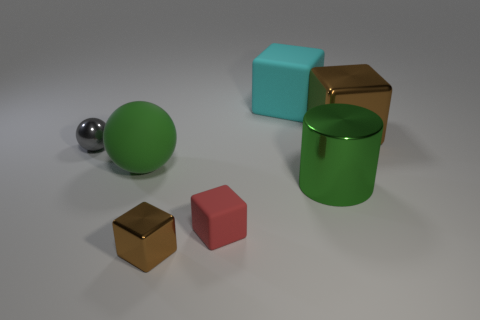What color is the small block in front of the tiny rubber object that is to the right of the brown metallic block in front of the red rubber block?
Provide a succinct answer. Brown. What is the shape of the brown metallic thing that is the same size as the cyan matte block?
Provide a short and direct response. Cube. Do the metallic block to the right of the tiny brown thing and the brown shiny thing that is on the left side of the large cyan matte block have the same size?
Your response must be concise. No. There is a rubber thing that is behind the matte sphere; what is its size?
Make the answer very short. Large. There is a cylinder that is the same color as the big rubber sphere; what is its material?
Your response must be concise. Metal. What is the color of the ball that is the same size as the red matte cube?
Provide a short and direct response. Gray. Is the gray metal ball the same size as the cyan block?
Your answer should be compact. No. There is a metallic thing that is on the left side of the large green cylinder and in front of the gray sphere; how big is it?
Your answer should be compact. Small. How many metallic things are large cubes or cyan blocks?
Provide a succinct answer. 1. Is the number of tiny shiny things that are right of the gray thing greater than the number of big blue objects?
Your answer should be compact. Yes. 